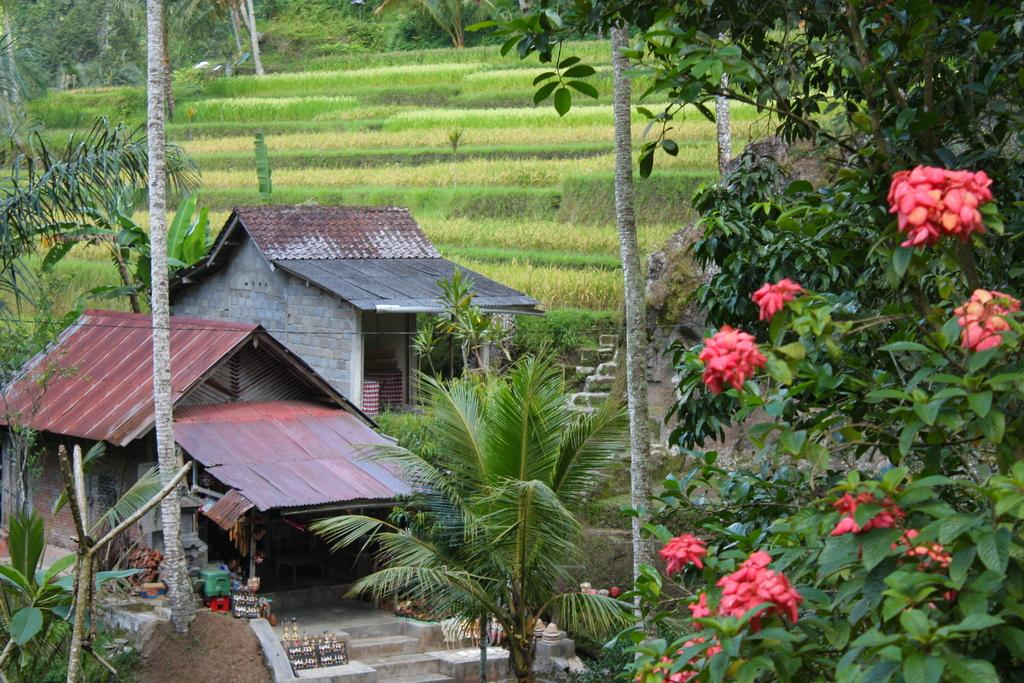What is the main subject in the center of the image? There are tents in the center of the image. What can be seen in the front of the image? There is a flower in the front of the image. What type of vegetation is present in the image? There are trees in the image. What is the ground covered with in the background of the image? There is grass on the ground in the background of the image. What else can be seen in the background of the image? There are trees in the background of the image. How many houses are visible in the image? There are no houses visible in the image; it features tents, a flower, trees, and grass. Can you tell me how many passengers are sitting inside the tents? There are no passengers present in the image, as it features tents, a flower, trees, and grass. 